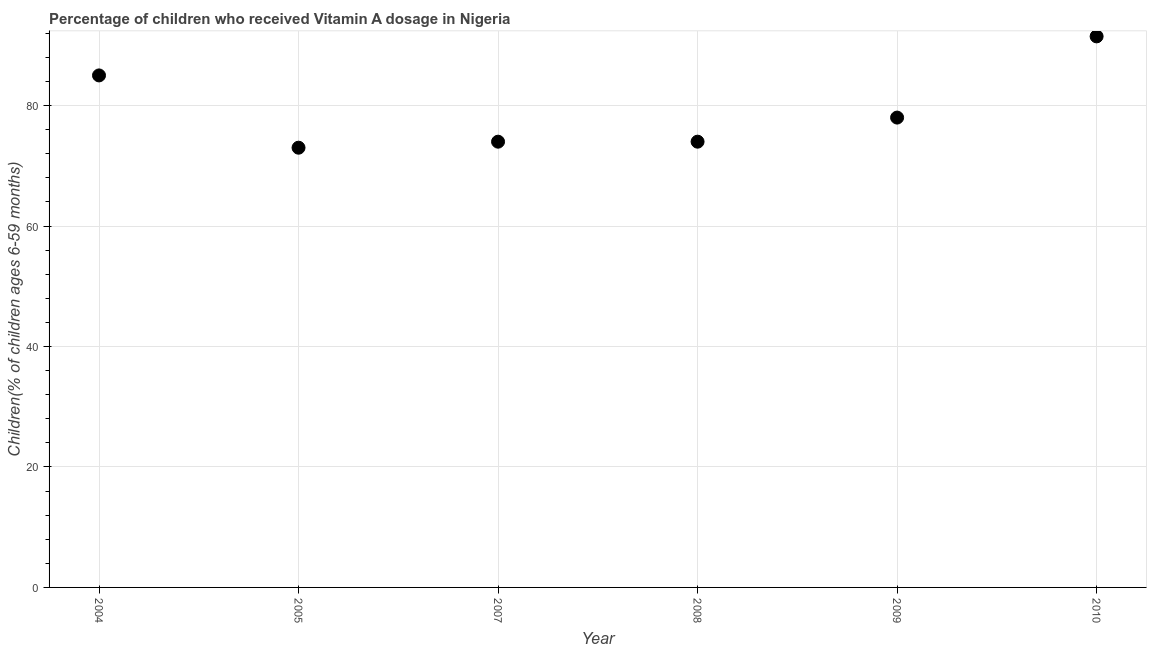What is the vitamin a supplementation coverage rate in 2007?
Make the answer very short. 74. Across all years, what is the maximum vitamin a supplementation coverage rate?
Offer a very short reply. 91.48. Across all years, what is the minimum vitamin a supplementation coverage rate?
Make the answer very short. 73. In which year was the vitamin a supplementation coverage rate minimum?
Provide a succinct answer. 2005. What is the sum of the vitamin a supplementation coverage rate?
Offer a very short reply. 475.48. What is the average vitamin a supplementation coverage rate per year?
Provide a short and direct response. 79.25. In how many years, is the vitamin a supplementation coverage rate greater than 28 %?
Provide a short and direct response. 6. What is the ratio of the vitamin a supplementation coverage rate in 2007 to that in 2008?
Your answer should be very brief. 1. What is the difference between the highest and the second highest vitamin a supplementation coverage rate?
Your response must be concise. 6.48. Is the sum of the vitamin a supplementation coverage rate in 2005 and 2008 greater than the maximum vitamin a supplementation coverage rate across all years?
Make the answer very short. Yes. What is the difference between the highest and the lowest vitamin a supplementation coverage rate?
Ensure brevity in your answer.  18.48. In how many years, is the vitamin a supplementation coverage rate greater than the average vitamin a supplementation coverage rate taken over all years?
Make the answer very short. 2. Does the vitamin a supplementation coverage rate monotonically increase over the years?
Offer a very short reply. No. What is the difference between two consecutive major ticks on the Y-axis?
Give a very brief answer. 20. What is the title of the graph?
Offer a terse response. Percentage of children who received Vitamin A dosage in Nigeria. What is the label or title of the X-axis?
Your response must be concise. Year. What is the label or title of the Y-axis?
Offer a terse response. Children(% of children ages 6-59 months). What is the Children(% of children ages 6-59 months) in 2004?
Your response must be concise. 85. What is the Children(% of children ages 6-59 months) in 2005?
Ensure brevity in your answer.  73. What is the Children(% of children ages 6-59 months) in 2009?
Offer a terse response. 78. What is the Children(% of children ages 6-59 months) in 2010?
Offer a terse response. 91.48. What is the difference between the Children(% of children ages 6-59 months) in 2004 and 2010?
Make the answer very short. -6.48. What is the difference between the Children(% of children ages 6-59 months) in 2005 and 2007?
Ensure brevity in your answer.  -1. What is the difference between the Children(% of children ages 6-59 months) in 2005 and 2010?
Ensure brevity in your answer.  -18.48. What is the difference between the Children(% of children ages 6-59 months) in 2007 and 2008?
Keep it short and to the point. 0. What is the difference between the Children(% of children ages 6-59 months) in 2007 and 2010?
Keep it short and to the point. -17.48. What is the difference between the Children(% of children ages 6-59 months) in 2008 and 2010?
Offer a terse response. -17.48. What is the difference between the Children(% of children ages 6-59 months) in 2009 and 2010?
Give a very brief answer. -13.48. What is the ratio of the Children(% of children ages 6-59 months) in 2004 to that in 2005?
Offer a very short reply. 1.16. What is the ratio of the Children(% of children ages 6-59 months) in 2004 to that in 2007?
Your response must be concise. 1.15. What is the ratio of the Children(% of children ages 6-59 months) in 2004 to that in 2008?
Give a very brief answer. 1.15. What is the ratio of the Children(% of children ages 6-59 months) in 2004 to that in 2009?
Keep it short and to the point. 1.09. What is the ratio of the Children(% of children ages 6-59 months) in 2004 to that in 2010?
Give a very brief answer. 0.93. What is the ratio of the Children(% of children ages 6-59 months) in 2005 to that in 2007?
Offer a terse response. 0.99. What is the ratio of the Children(% of children ages 6-59 months) in 2005 to that in 2009?
Provide a short and direct response. 0.94. What is the ratio of the Children(% of children ages 6-59 months) in 2005 to that in 2010?
Your answer should be very brief. 0.8. What is the ratio of the Children(% of children ages 6-59 months) in 2007 to that in 2008?
Your answer should be very brief. 1. What is the ratio of the Children(% of children ages 6-59 months) in 2007 to that in 2009?
Your answer should be compact. 0.95. What is the ratio of the Children(% of children ages 6-59 months) in 2007 to that in 2010?
Ensure brevity in your answer.  0.81. What is the ratio of the Children(% of children ages 6-59 months) in 2008 to that in 2009?
Give a very brief answer. 0.95. What is the ratio of the Children(% of children ages 6-59 months) in 2008 to that in 2010?
Your answer should be compact. 0.81. What is the ratio of the Children(% of children ages 6-59 months) in 2009 to that in 2010?
Your answer should be compact. 0.85. 